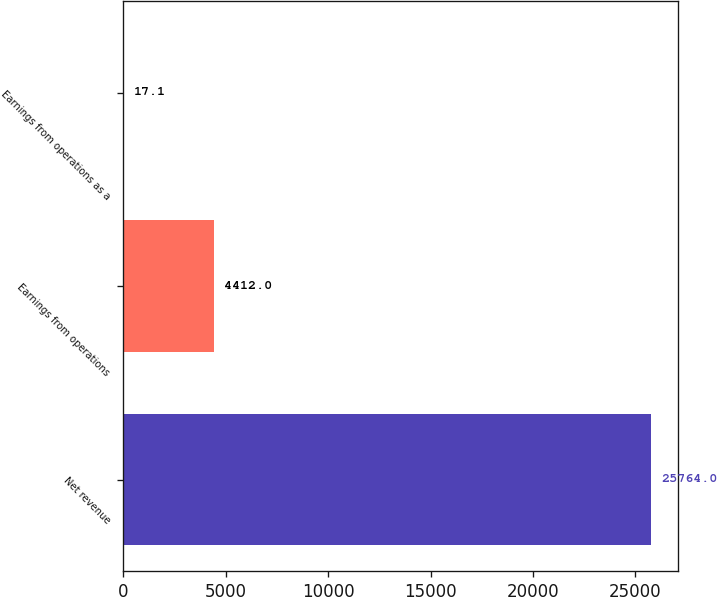Convert chart. <chart><loc_0><loc_0><loc_500><loc_500><bar_chart><fcel>Net revenue<fcel>Earnings from operations<fcel>Earnings from operations as a<nl><fcel>25764<fcel>4412<fcel>17.1<nl></chart> 